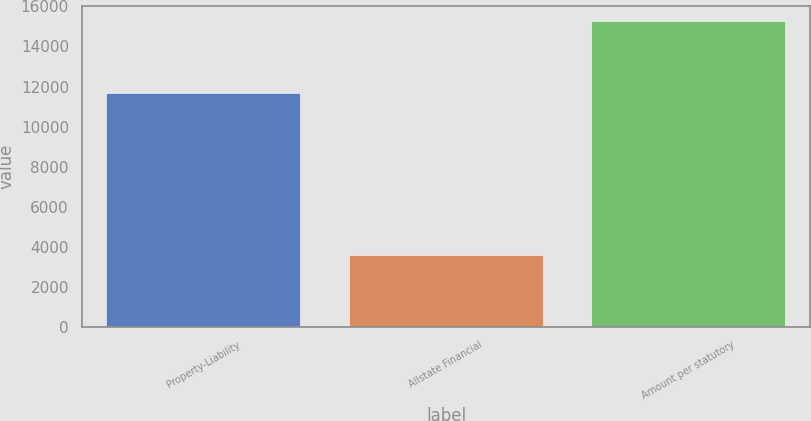Convert chart. <chart><loc_0><loc_0><loc_500><loc_500><bar_chart><fcel>Property-Liability<fcel>Allstate Financial<fcel>Amount per statutory<nl><fcel>11679<fcel>3588<fcel>15267<nl></chart> 